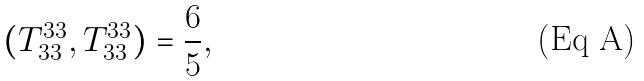<formula> <loc_0><loc_0><loc_500><loc_500>( T ^ { 3 3 } _ { 3 3 } , T ^ { 3 3 } _ { 3 3 } ) = \frac { 6 } { 5 } ,</formula> 